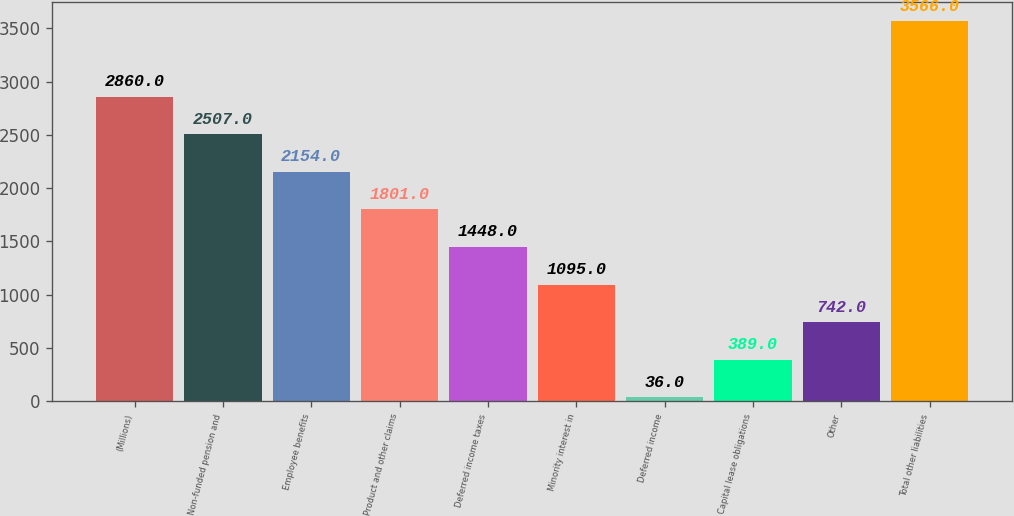Convert chart. <chart><loc_0><loc_0><loc_500><loc_500><bar_chart><fcel>(Millions)<fcel>Non-funded pension and<fcel>Employee benefits<fcel>Product and other claims<fcel>Deferred income taxes<fcel>Minority interest in<fcel>Deferred income<fcel>Capital lease obligations<fcel>Other<fcel>Total other liabilities<nl><fcel>2860<fcel>2507<fcel>2154<fcel>1801<fcel>1448<fcel>1095<fcel>36<fcel>389<fcel>742<fcel>3566<nl></chart> 